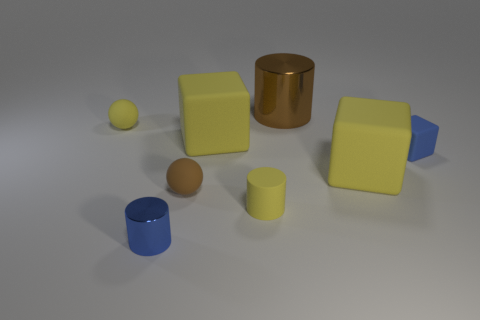Subtract all blue blocks. Subtract all blue balls. How many blocks are left? 2 Add 1 big brown shiny things. How many objects exist? 9 Subtract all spheres. How many objects are left? 6 Add 8 big shiny cylinders. How many big shiny cylinders are left? 9 Add 7 big objects. How many big objects exist? 10 Subtract 0 cyan cylinders. How many objects are left? 8 Subtract all matte balls. Subtract all brown matte spheres. How many objects are left? 5 